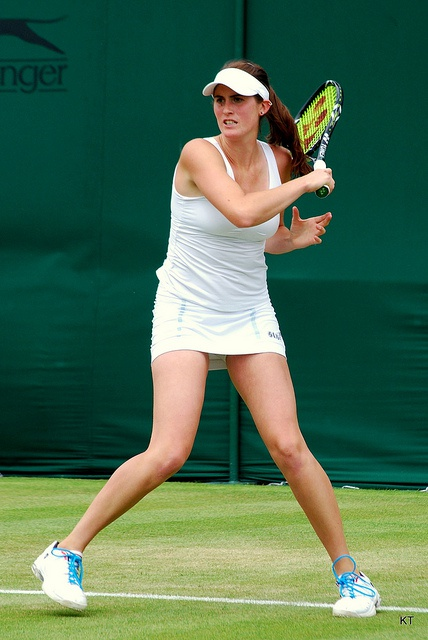Describe the objects in this image and their specific colors. I can see people in darkgreen, white, tan, and salmon tones and tennis racket in darkgreen, black, khaki, lightgreen, and olive tones in this image. 